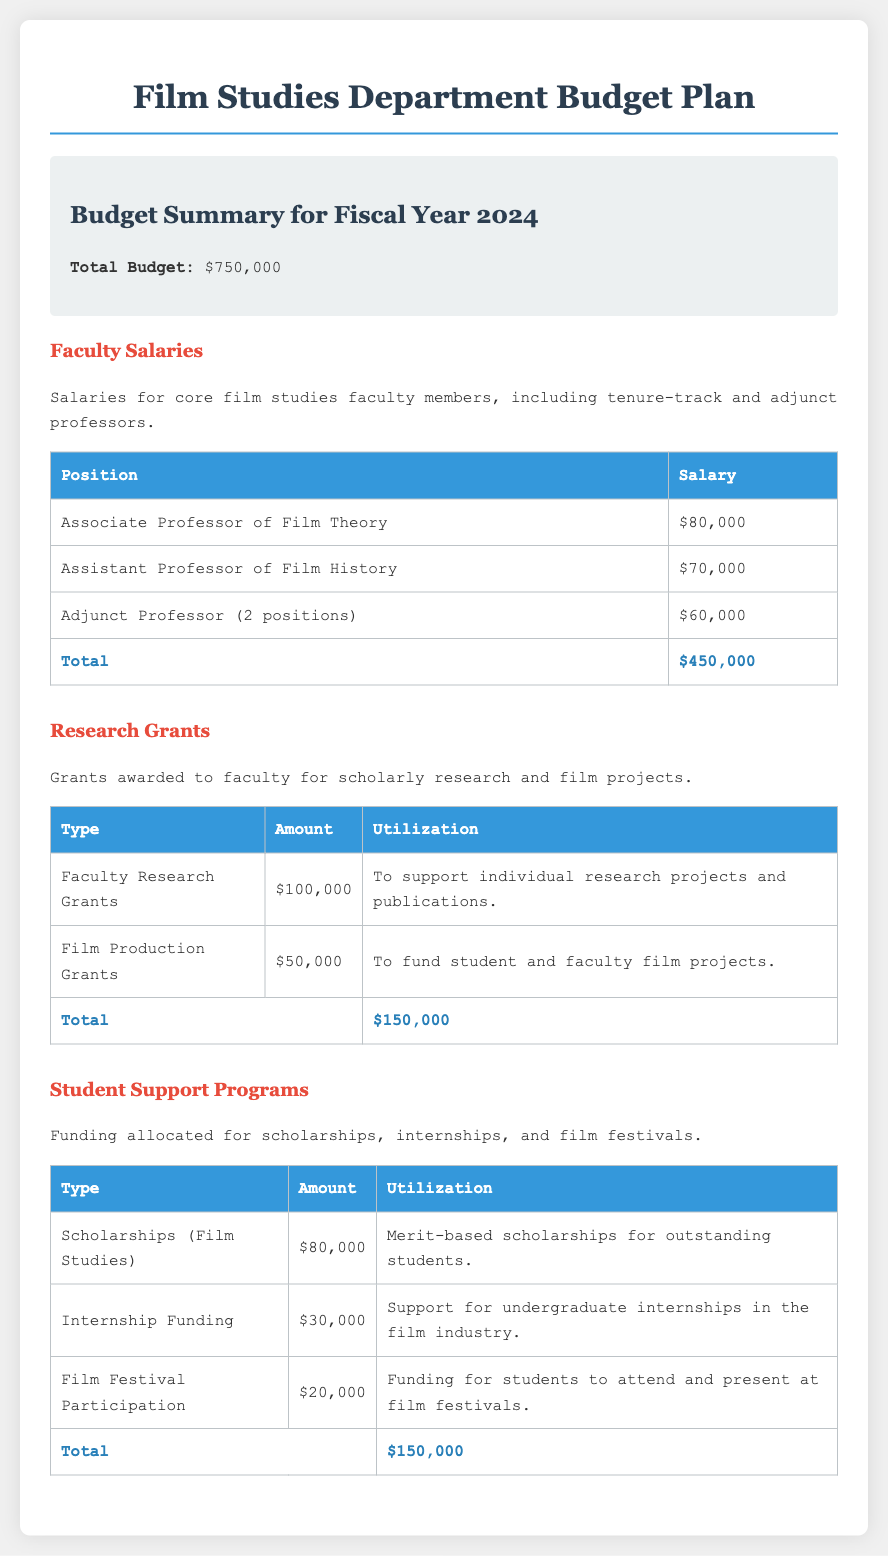What is the total budget? The total budget is stated at the beginning of the document as $750,000.
Answer: $750,000 What is the salary of the Associate Professor of Film Theory? The document lists the salary for the Associate Professor of Film Theory as $80,000.
Answer: $80,000 How much is allocated for student scholarships in Film Studies? This information can be found in the Student Support Programs section, which states that $80,000 is allocated for scholarships.
Answer: $80,000 What is the total amount for Faculty Research Grants? The document specifies that the total amount for Faculty Research Grants is $100,000.
Answer: $100,000 How many types of Student Support Programs are listed? The table under Student Support Programs includes three types: Scholarships, Internship Funding, and Film Festival Participation.
Answer: Three types What is the total amount allocated for Research Grants? The combined total for Research Grants can be found in the corresponding section, totaling $150,000.
Answer: $150,000 What is the purpose of the Film Production Grants? The document states that Film Production Grants are meant to fund student and faculty film projects.
Answer: To fund student and faculty film projects How much is designated for internship funding? Internship funding is specifically allocated $30,000, according to the budget details.
Answer: $30,000 What category has the highest funding in the budget? The Faculty Salaries category has the highest funding amount, totaling $450,000.
Answer: Faculty Salaries 